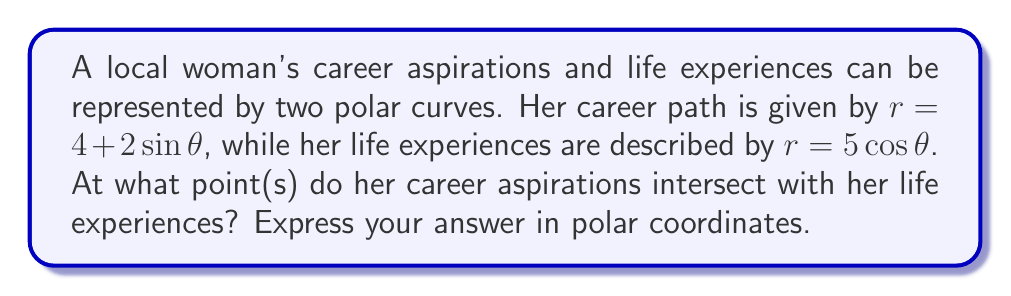Give your solution to this math problem. To find the intersection points of these two polar curves, we need to set the equations equal to each other and solve for $\theta$:

$$4 + 2\sin\theta = 5\cos\theta$$

Rearranging the equation:

$$4 = 5\cos\theta - 2\sin\theta$$

We can use the identity $a\cos\theta + b\sin\theta = \sqrt{a^2 + b^2}\cos(\theta - \arctan(\frac{b}{a}))$:

$$4 = \sqrt{5^2 + (-2)^2}\cos(\theta - \arctan(\frac{-2}{5}))$$

$$4 = \sqrt{29}\cos(\theta - \arctan(-0.4))$$

$$\frac{4}{\sqrt{29}} = \cos(\theta + 0.3805)$$

Using the arccosine function:

$$\theta + 0.3805 = \pm\arccos(\frac{4}{\sqrt{29}})$$

$$\theta = -0.3805 \pm \arccos(\frac{4}{\sqrt{29}})$$

This gives us two solutions:

$$\theta_1 = -0.3805 + \arccos(\frac{4}{\sqrt{29}}) \approx 0.9553$$
$$\theta_2 = -0.3805 - \arccos(\frac{4}{\sqrt{29}}) \approx -1.7163$$

To find the corresponding $r$ values, we can substitute these $\theta$ values into either of the original equations. Let's use $r = 4 + 2\sin\theta$:

For $\theta_1$: $r_1 = 4 + 2\sin(0.9553) \approx 5.7321$
For $\theta_2$: $r_2 = 4 + 2\sin(-1.7163) \approx 3.2679$

Therefore, the intersection points in polar coordinates are approximately $(5.7321, 0.9553)$ and $(3.2679, -1.7163)$.
Answer: The intersection points are approximately $(5.7321, 0.9553)$ and $(3.2679, -1.7163)$ in polar coordinates $(r, \theta)$. 